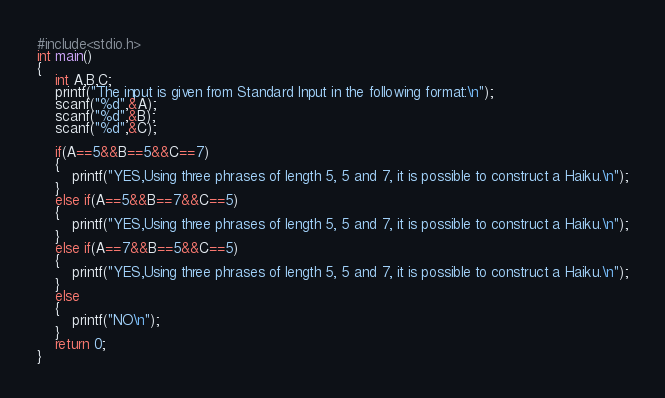Convert code to text. <code><loc_0><loc_0><loc_500><loc_500><_C_>#include<stdio.h>
int main()
{
	int A,B,C;
	printf("The input is given from Standard Input in the following format:\n");
	scanf("%d",&A);
	scanf("%d",&B);
	scanf("%d",&C);

	if(A==5&&B==5&&C==7)
	{
		printf("YES,Using three phrases of length 5, 5 and 7, it is possible to construct a Haiku.\n");
	}
	else if(A==5&&B==7&&C==5)
	{
		printf("YES,Using three phrases of length 5, 5 and 7, it is possible to construct a Haiku.\n");
	}
	else if(A==7&&B==5&&C==5)
	{
		printf("YES,Using three phrases of length 5, 5 and 7, it is possible to construct a Haiku.\n");
	}
	else
	{
		printf("NO\n");
	}
	return 0;
}


</code> 